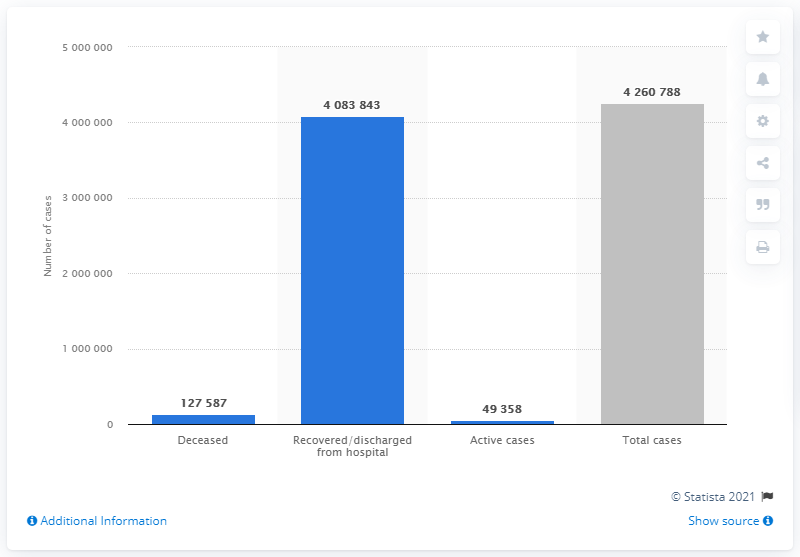Draw attention to some important aspects in this diagram. As of July 1, 2021, there were 49,358 active cases of COVID-19 in Italy. 